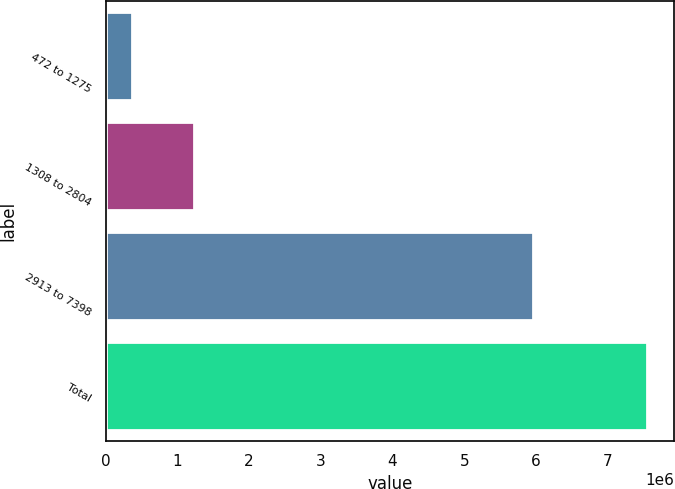Convert chart. <chart><loc_0><loc_0><loc_500><loc_500><bar_chart><fcel>472 to 1275<fcel>1308 to 2804<fcel>2913 to 7398<fcel>Total<nl><fcel>366523<fcel>1.22473e+06<fcel>5.95657e+06<fcel>7.54782e+06<nl></chart> 